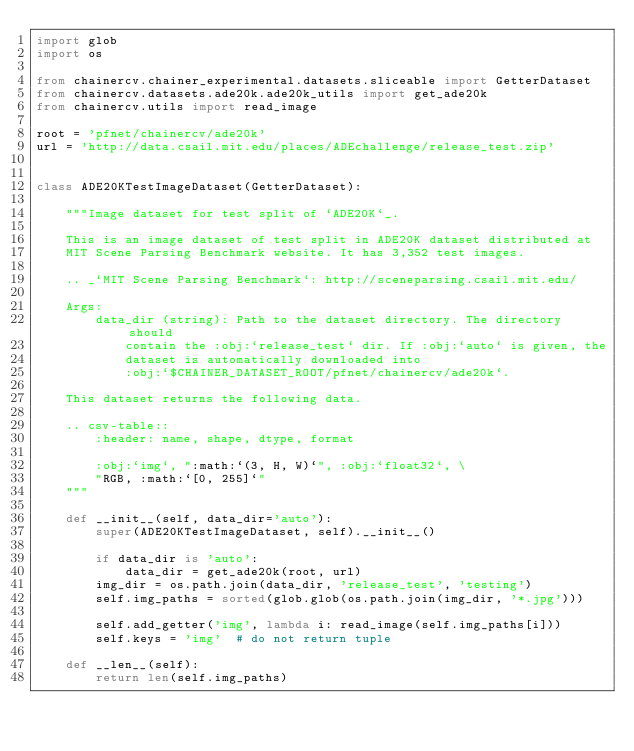Convert code to text. <code><loc_0><loc_0><loc_500><loc_500><_Python_>import glob
import os

from chainercv.chainer_experimental.datasets.sliceable import GetterDataset
from chainercv.datasets.ade20k.ade20k_utils import get_ade20k
from chainercv.utils import read_image

root = 'pfnet/chainercv/ade20k'
url = 'http://data.csail.mit.edu/places/ADEchallenge/release_test.zip'


class ADE20KTestImageDataset(GetterDataset):

    """Image dataset for test split of `ADE20K`_.

    This is an image dataset of test split in ADE20K dataset distributed at
    MIT Scene Parsing Benchmark website. It has 3,352 test images.

    .. _`MIT Scene Parsing Benchmark`: http://sceneparsing.csail.mit.edu/

    Args:
        data_dir (string): Path to the dataset directory. The directory should
            contain the :obj:`release_test` dir. If :obj:`auto` is given, the
            dataset is automatically downloaded into
            :obj:`$CHAINER_DATASET_ROOT/pfnet/chainercv/ade20k`.

    This dataset returns the following data.

    .. csv-table::
        :header: name, shape, dtype, format

        :obj:`img`, ":math:`(3, H, W)`", :obj:`float32`, \
        "RGB, :math:`[0, 255]`"
    """

    def __init__(self, data_dir='auto'):
        super(ADE20KTestImageDataset, self).__init__()

        if data_dir is 'auto':
            data_dir = get_ade20k(root, url)
        img_dir = os.path.join(data_dir, 'release_test', 'testing')
        self.img_paths = sorted(glob.glob(os.path.join(img_dir, '*.jpg')))

        self.add_getter('img', lambda i: read_image(self.img_paths[i]))
        self.keys = 'img'  # do not return tuple

    def __len__(self):
        return len(self.img_paths)
</code> 